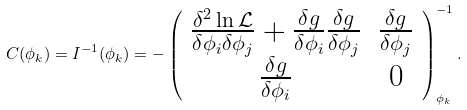<formula> <loc_0><loc_0><loc_500><loc_500>C ( \phi _ { k } ) = I ^ { - 1 } ( \phi _ { k } ) = - \left ( \begin{array} { c c } \frac { \delta ^ { 2 } \ln \mathcal { L } } { \delta \phi _ { i } \delta \phi _ { j } } + \frac { \delta g } { \delta \phi _ { i } } \frac { \delta g } { \delta \phi _ { j } } & \frac { \delta g } { \delta \phi _ { j } } \\ \frac { \delta g } { \delta \phi _ { i } } & 0 \end{array} \right ) _ { \phi _ { k } } ^ { - 1 } .</formula> 